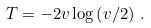Convert formula to latex. <formula><loc_0><loc_0><loc_500><loc_500>T = - 2 v \log \left ( v / 2 \right ) \, .</formula> 